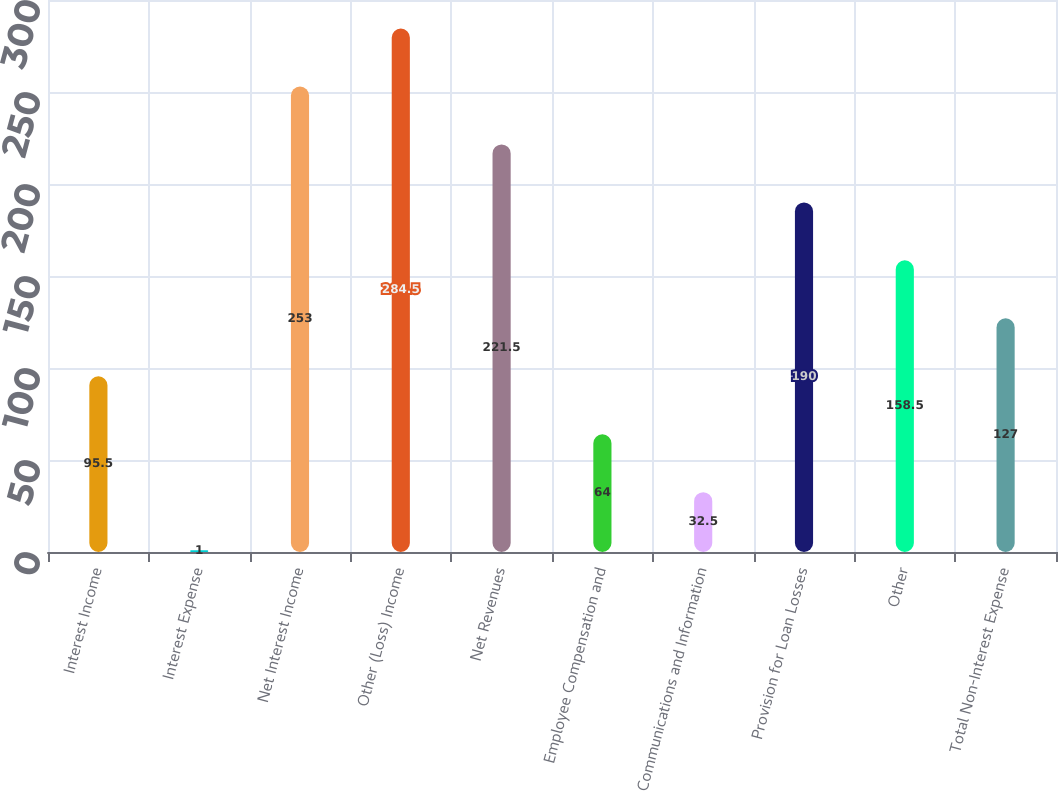Convert chart. <chart><loc_0><loc_0><loc_500><loc_500><bar_chart><fcel>Interest Income<fcel>Interest Expense<fcel>Net Interest Income<fcel>Other (Loss) Income<fcel>Net Revenues<fcel>Employee Compensation and<fcel>Communications and Information<fcel>Provision for Loan Losses<fcel>Other<fcel>Total Non-Interest Expense<nl><fcel>95.5<fcel>1<fcel>253<fcel>284.5<fcel>221.5<fcel>64<fcel>32.5<fcel>190<fcel>158.5<fcel>127<nl></chart> 